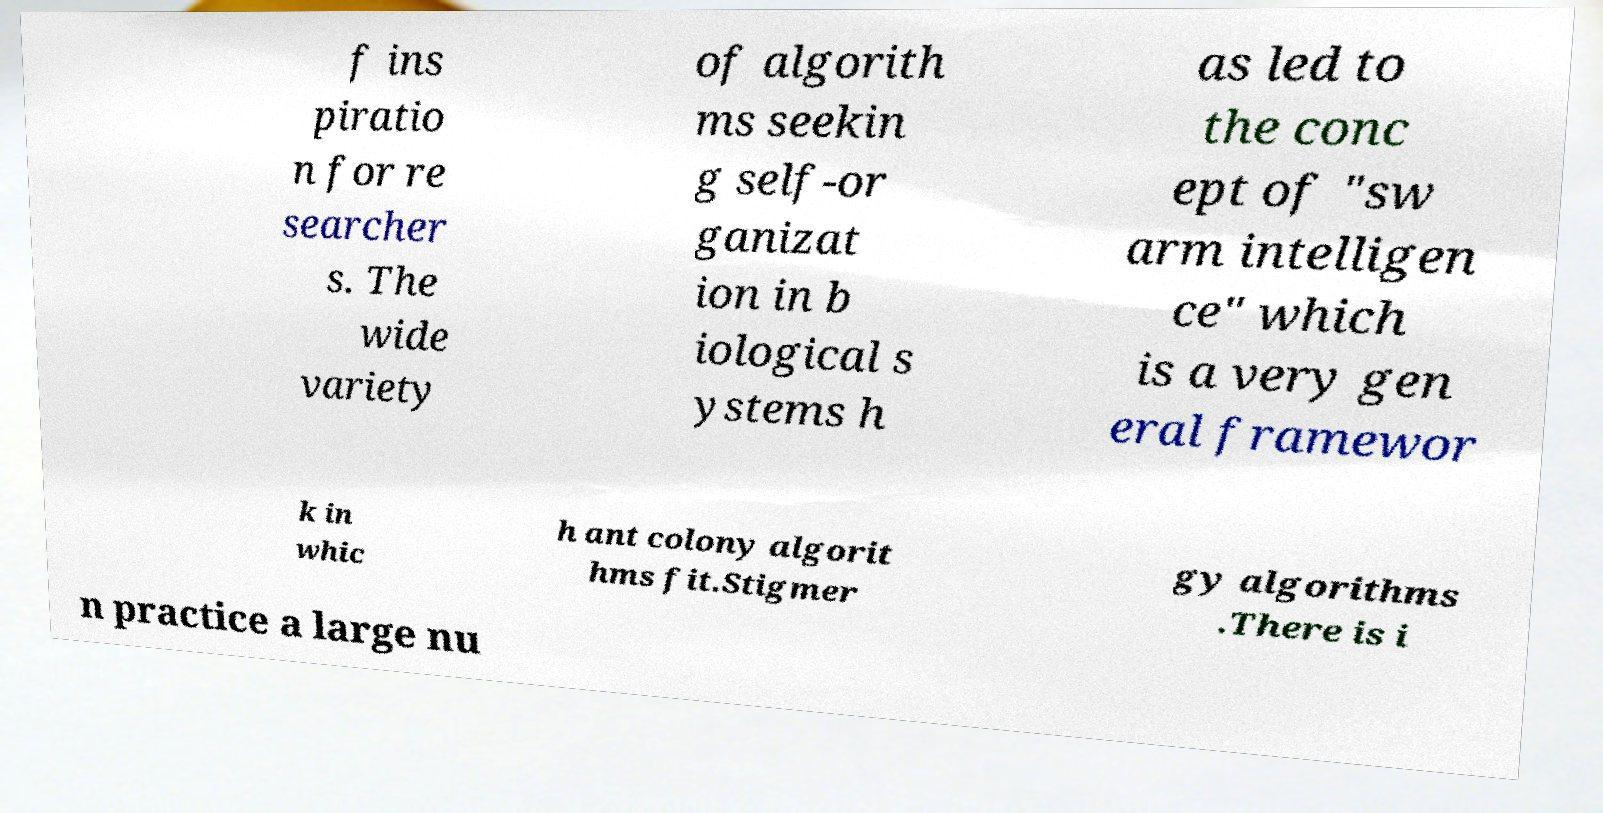There's text embedded in this image that I need extracted. Can you transcribe it verbatim? f ins piratio n for re searcher s. The wide variety of algorith ms seekin g self-or ganizat ion in b iological s ystems h as led to the conc ept of "sw arm intelligen ce" which is a very gen eral framewor k in whic h ant colony algorit hms fit.Stigmer gy algorithms .There is i n practice a large nu 